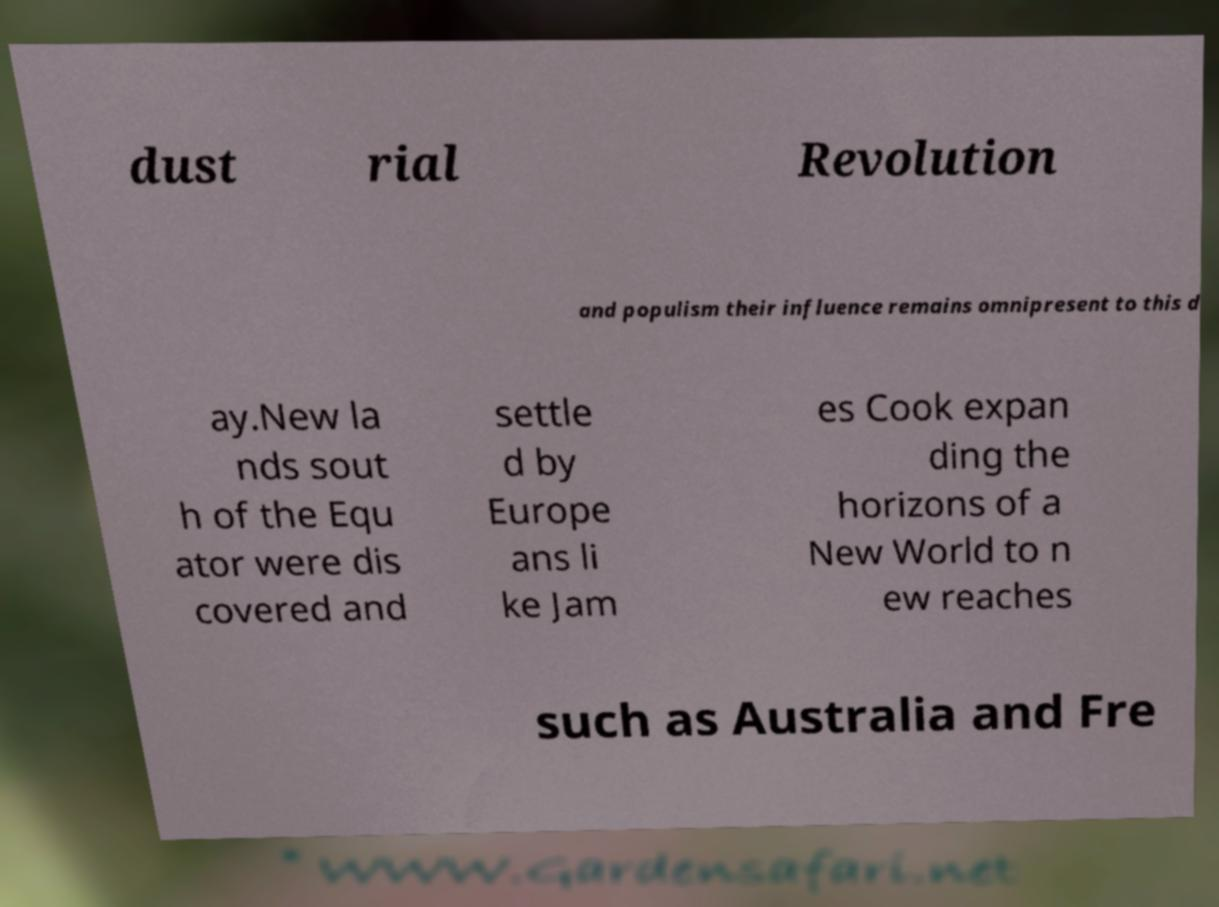Can you read and provide the text displayed in the image?This photo seems to have some interesting text. Can you extract and type it out for me? dust rial Revolution and populism their influence remains omnipresent to this d ay.New la nds sout h of the Equ ator were dis covered and settle d by Europe ans li ke Jam es Cook expan ding the horizons of a New World to n ew reaches such as Australia and Fre 